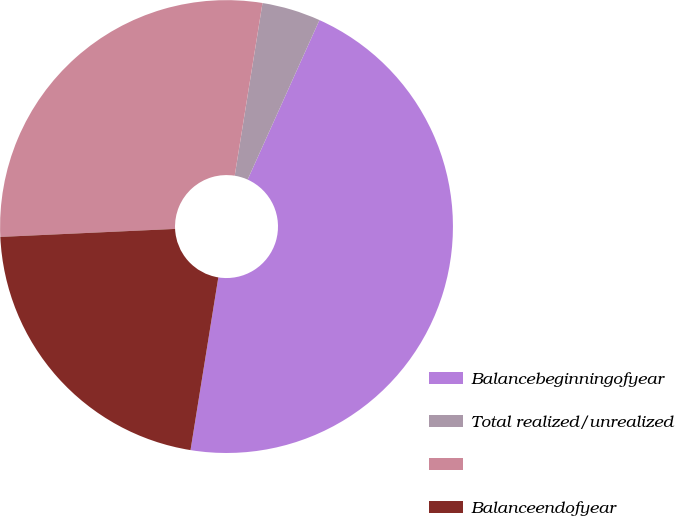Convert chart to OTSL. <chart><loc_0><loc_0><loc_500><loc_500><pie_chart><fcel>Balancebeginningofyear<fcel>Total realized/unrealized<fcel>Unnamed: 2<fcel>Balanceendofyear<nl><fcel>45.81%<fcel>4.19%<fcel>28.27%<fcel>21.73%<nl></chart> 